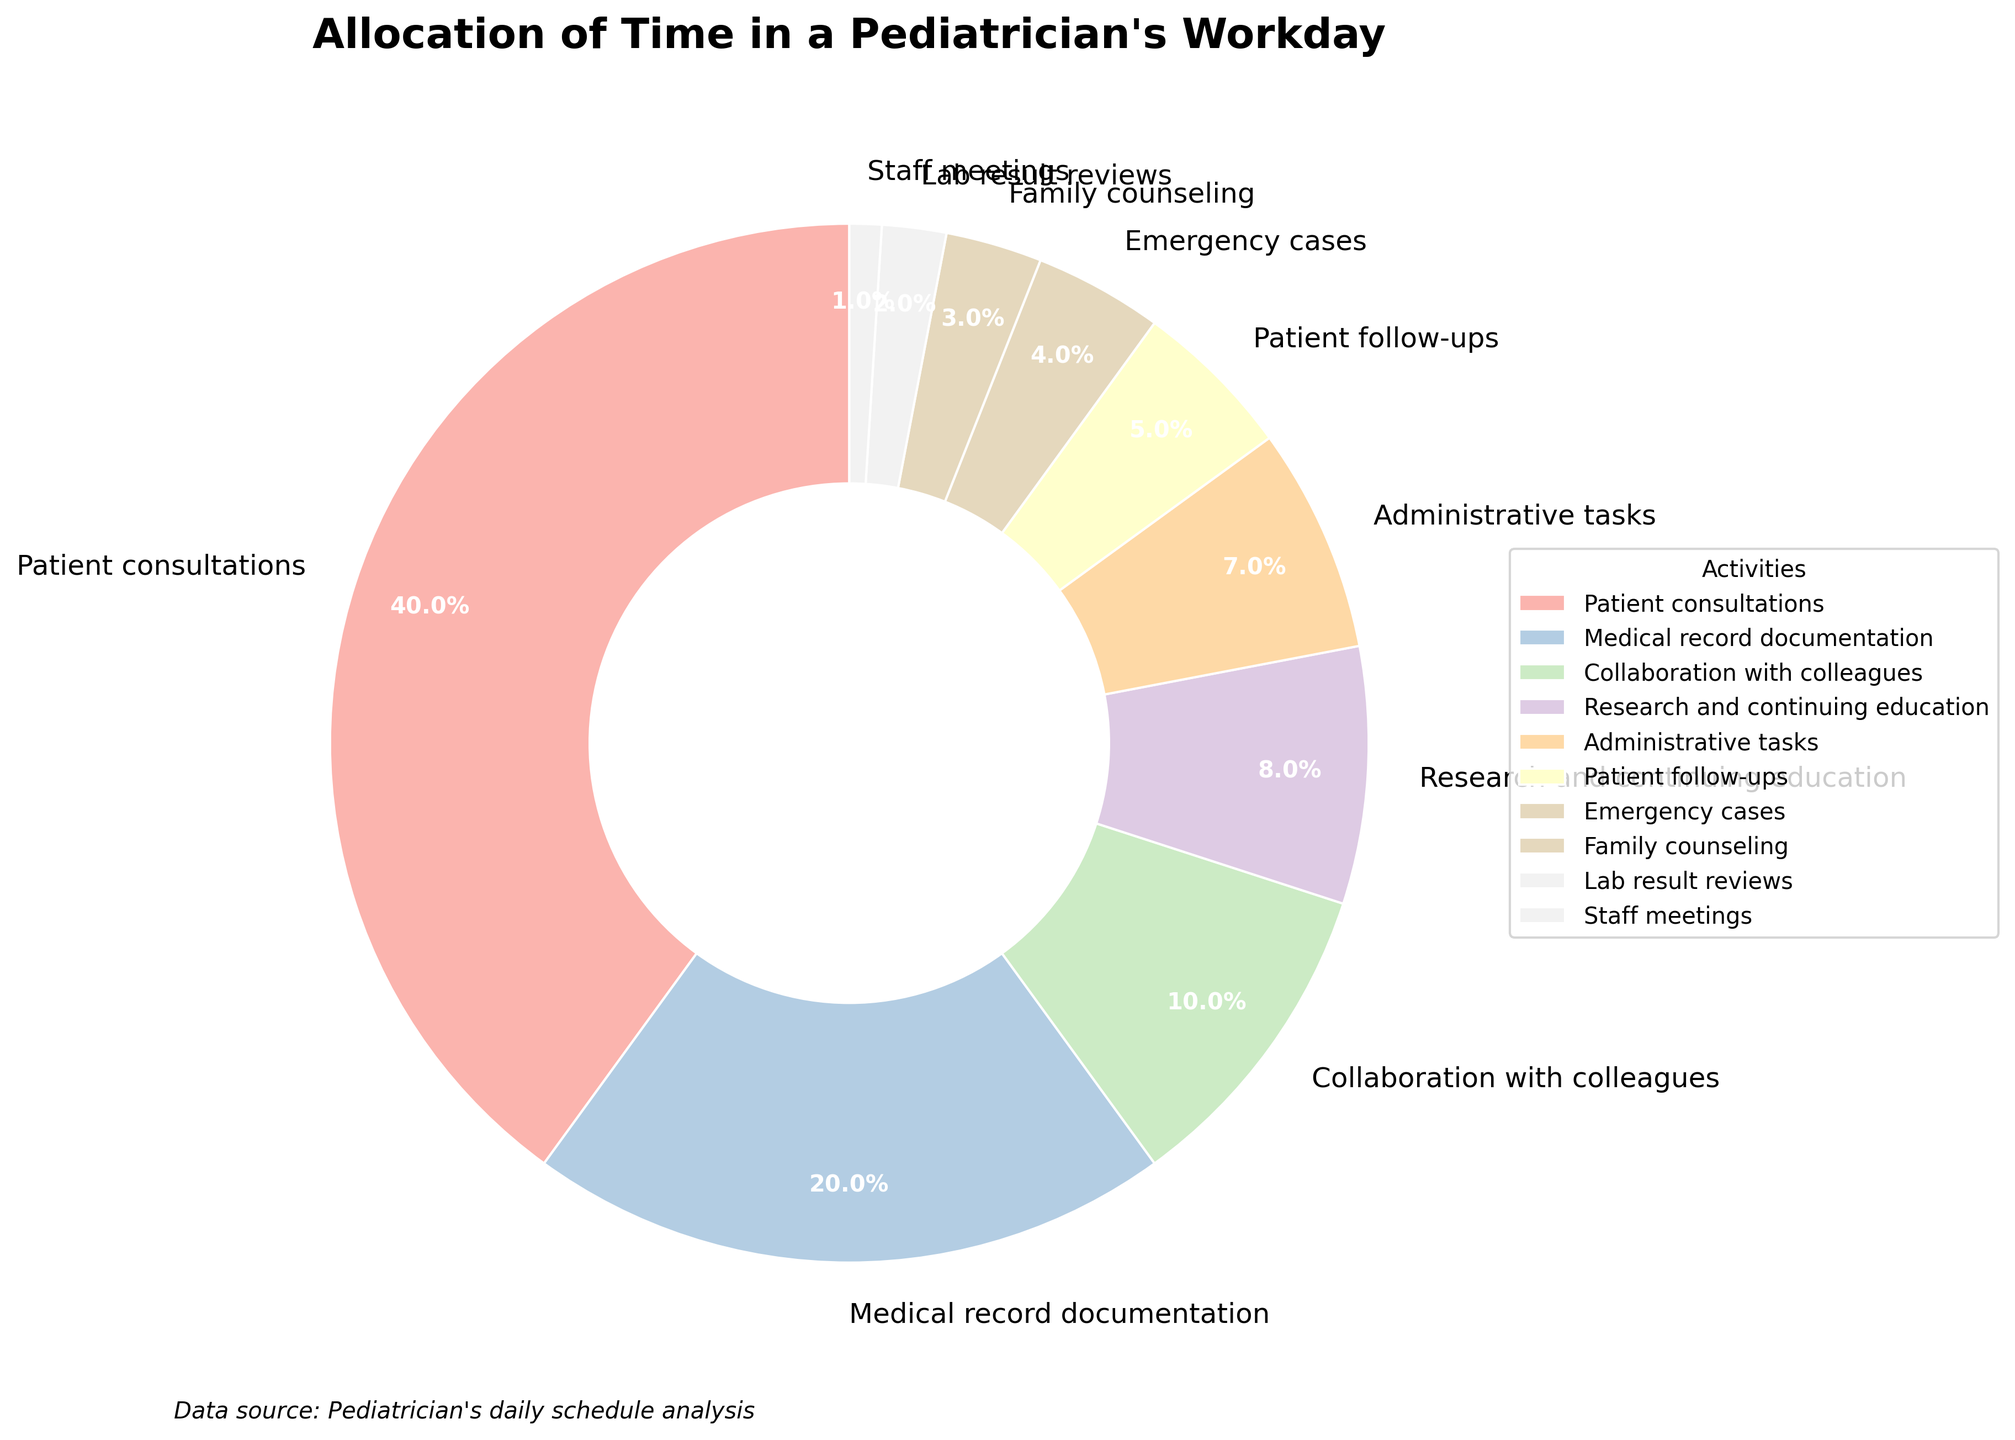Which activity takes up the largest portion of a pediatrician's workday? The largest portion on the pie chart corresponds to "Patient consultations" with 40%, indicated by the biggest wedge in the chart.
Answer: Patient consultations How much time in percentage is spent on "Collaboration with colleagues" and "Research and continuing education" together? To find the total percentage for these two activities, sum their individual percentages: 10% for "Collaboration with colleagues" and 8% for "Research and continuing education". The total is 10% + 8% = 18%.
Answer: 18% Which activity is allocated the least amount of time? The smallest wedge on the pie chart corresponds to "Staff meetings" with 1%.
Answer: Staff meetings Is more time spent on "Patient follow-ups" or on "Administrative tasks"? By comparing the wedges, "Administrative tasks" take up 7%, while "Patient follow-ups" take up 5%. Thus, more time is spent on "Administrative tasks".
Answer: Administrative tasks What percentage of the workday is spent on activities that involve direct patient interaction (Patient consultations, Patient follow-ups, Emergency cases, Family counseling)? Add the percentages for "Patient consultations" (40%), "Patient follow-ups" (5%), "Emergency cases" (4%), and "Family counseling" (3%). The total is 40% + 5% + 4% + 3% = 52%.
Answer: 52% Compare the percentages of time spent on "Medical record documentation" and "Administrative tasks" and state the difference. The percentage for "Medical record documentation" is 20% and for "Administrative tasks" is 7%. The difference is 20% - 7% = 13%.
Answer: 13% What is the combined percentage of the three activities that take up the most time? The three activities with the highest percentages are "Patient consultations" (40%), "Medical record documentation" (20%), and "Collaboration with colleagues" (10%). Adding these gives 40% + 20% + 10% = 70%.
Answer: 70% Is the percentage of time spent on "Research and continuing education" more than the combined percentage of "Family counseling" and "Lab result reviews"? "Research and continuing education" is 8%. "Family counseling" is 3% and "Lab result reviews" is 2%. The combined percentage for the latter two is 3% + 2% = 5%. Since 8% > 5%, more time is spent on "Research and continuing education".
Answer: Yes What is the proportion of time spent on activities related to documentation ("Medical record documentation" and "Lab result reviews")? Sum the percentages for "Medical record documentation" (20%) and "Lab result reviews" (2%). The total is 20% + 2% = 22%. Therefore, the proportion is 22%.
Answer: 22% How does the percentage of time spent on "Emergency cases" compare with "Family counseling"? "Emergency cases" take up 4% of the time, while "Family counseling" accounts for 3%. Therefore, the percentage for "Emergency cases" is higher by 1%.
Answer: 4% > 3% 